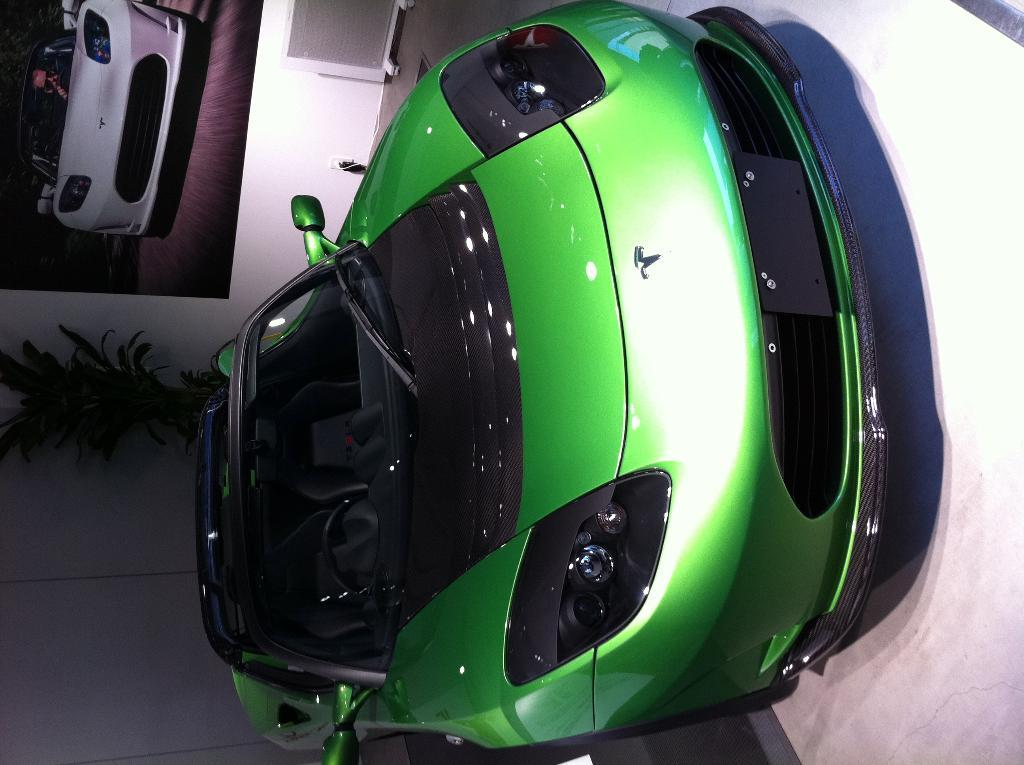What type of car can be seen in the image? There is a green car in the image. What else is present in the image besides the car? There is a wall and a photo of a car on the wall in the image. Can you describe the plant in the image? There is a green plant in the image. What type of farming equipment is visible in the image? There is no farming equipment present in the image. What type of fuel is being used by the car in the image? The type of fuel being used by the car in the image cannot be determined from the image alone. 